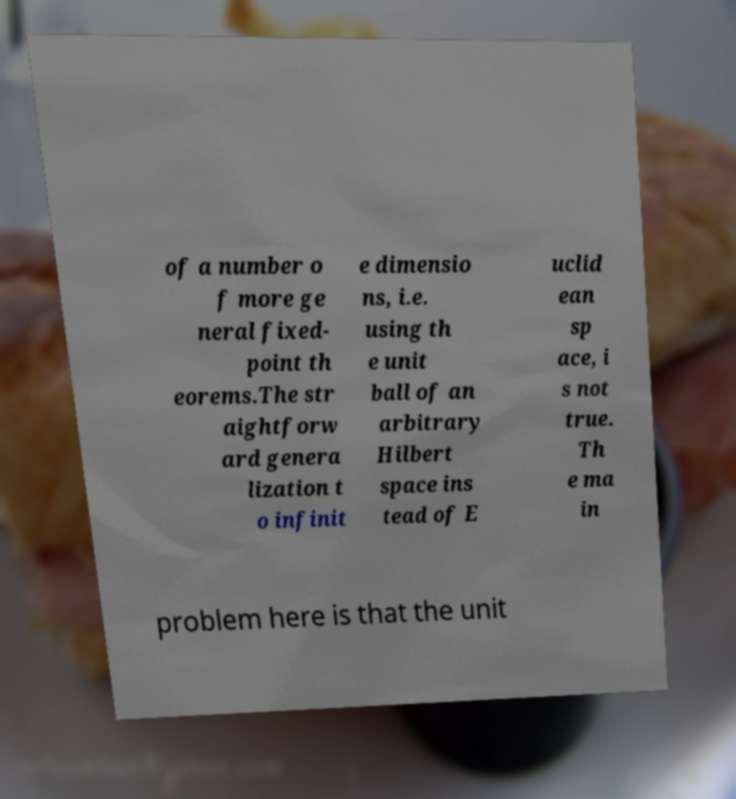For documentation purposes, I need the text within this image transcribed. Could you provide that? of a number o f more ge neral fixed- point th eorems.The str aightforw ard genera lization t o infinit e dimensio ns, i.e. using th e unit ball of an arbitrary Hilbert space ins tead of E uclid ean sp ace, i s not true. Th e ma in problem here is that the unit 